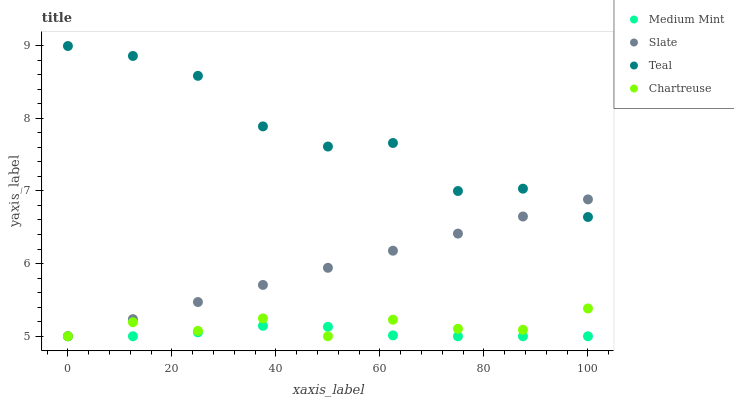Does Medium Mint have the minimum area under the curve?
Answer yes or no. Yes. Does Teal have the maximum area under the curve?
Answer yes or no. Yes. Does Slate have the minimum area under the curve?
Answer yes or no. No. Does Slate have the maximum area under the curve?
Answer yes or no. No. Is Slate the smoothest?
Answer yes or no. Yes. Is Teal the roughest?
Answer yes or no. Yes. Is Chartreuse the smoothest?
Answer yes or no. No. Is Chartreuse the roughest?
Answer yes or no. No. Does Medium Mint have the lowest value?
Answer yes or no. Yes. Does Teal have the lowest value?
Answer yes or no. No. Does Teal have the highest value?
Answer yes or no. Yes. Does Slate have the highest value?
Answer yes or no. No. Is Medium Mint less than Teal?
Answer yes or no. Yes. Is Teal greater than Chartreuse?
Answer yes or no. Yes. Does Medium Mint intersect Chartreuse?
Answer yes or no. Yes. Is Medium Mint less than Chartreuse?
Answer yes or no. No. Is Medium Mint greater than Chartreuse?
Answer yes or no. No. Does Medium Mint intersect Teal?
Answer yes or no. No. 